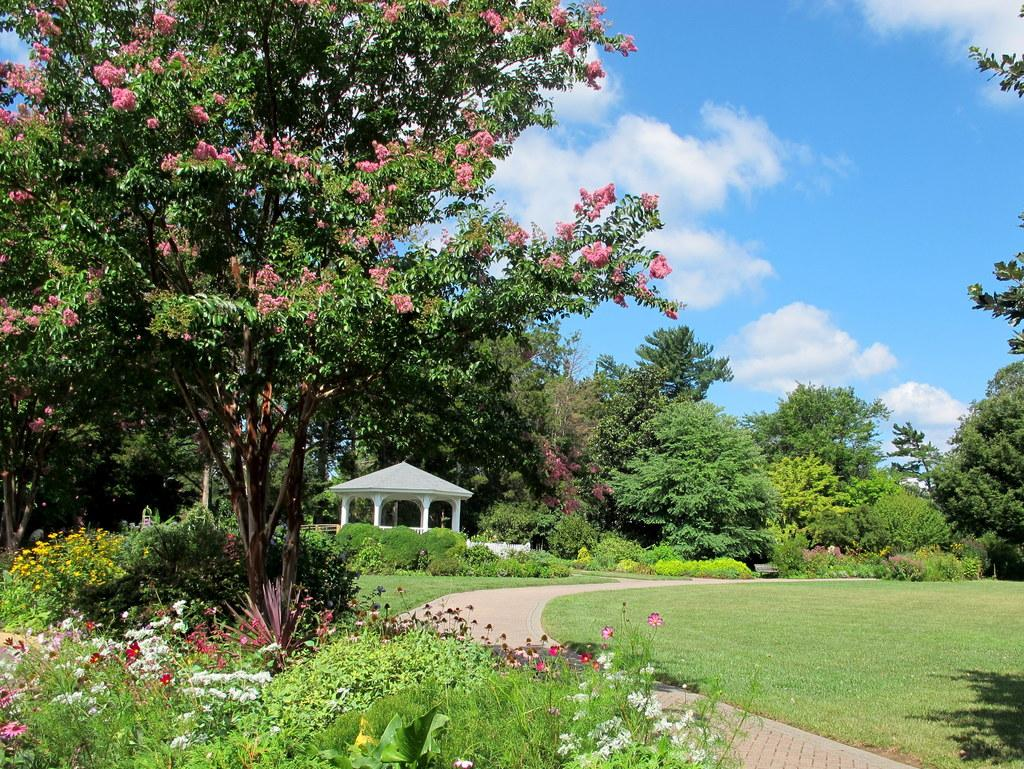What type of natural formation can be seen in the image? There is a rock structure in the image. What surrounds the rock structure? Trees, plants, and flowers are present around the rock structure. What is the condition of the grass in the image? The surface of the grass is visible. What can be seen in the background of the image? The sky is visible in the background of the image. What type of ring can be seen on the rock structure in the image? There is no ring present on the rock structure in the image. How many icicles are hanging from the trees in the image? There are no icicles present in the image, as it appears to be a warm and sunny scene. 